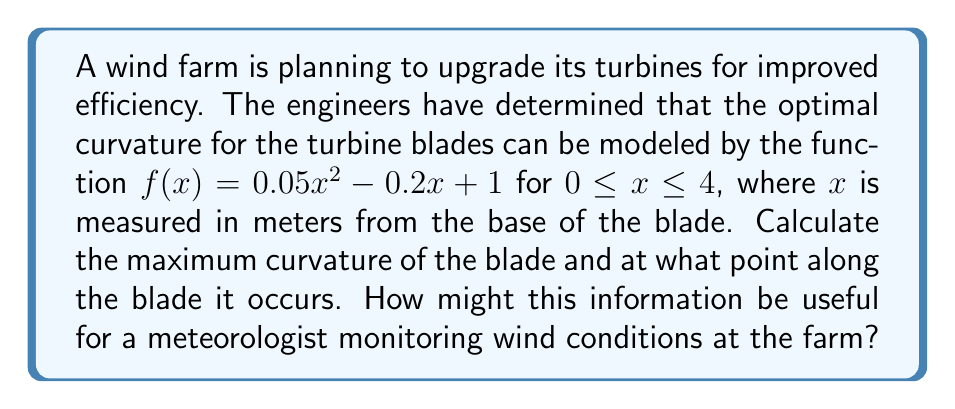Solve this math problem. To solve this problem, we'll follow these steps:

1) The curvature of a function $f(x)$ is given by the formula:

   $$\kappa = \frac{|f''(x)|}{(1 + [f'(x)]^2)^{3/2}}$$

2) First, we need to find $f'(x)$ and $f''(x)$:
   
   $f'(x) = 0.1x - 0.2$
   $f''(x) = 0.1$

3) Now we can substitute these into our curvature formula:

   $$\kappa = \frac{|0.1|}{(1 + [0.1x - 0.2]^2)^{3/2}}$$

4) To find the maximum curvature, we need to minimize the denominator. The denominator will be at its minimum when $[0.1x - 0.2]^2$ is at its minimum, which occurs when $0.1x - 0.2 = 0$.

5) Solving this equation:
   
   $0.1x - 0.2 = 0$
   $0.1x = 0.2$
   $x = 2$

6) Therefore, the maximum curvature occurs at $x = 2$ meters from the base of the blade.

7) To find the value of the maximum curvature, we substitute $x = 2$ into our curvature formula:

   $$\kappa_{max} = \frac{|0.1|}{(1 + [0.1(2) - 0.2]^2)^{3/2}} = \frac{0.1}{1^{3/2}} = 0.1$$

This information is useful for a meteorologist because the point of maximum curvature on a wind turbine blade is often where the blade is most sensitive to changes in wind speed and direction. Knowing this, the meteorologist can focus on providing detailed wind forecasts for the altitude corresponding to this point on the blade, helping the wind farm operators to optimize their turbine performance and predict energy output more accurately.

[asy]
size(200,200);
import graph;

real f(real x) {return 0.05*x^2 - 0.2*x + 1;}
draw(graph(f,0,4));

dot((2,f(2)),red);
label("Max curvature",
(2,f(2)),E);

xaxis("x (meters)",0,4,Arrow);
yaxis("y",0,1.5,Arrow);
[/asy]
Answer: The maximum curvature of the wind turbine blade is 0.1, occurring at 2 meters from the base of the blade. 